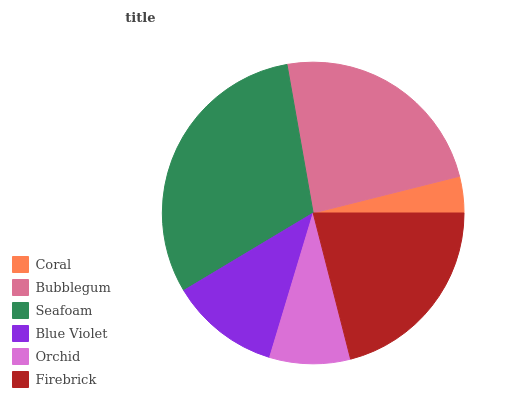Is Coral the minimum?
Answer yes or no. Yes. Is Seafoam the maximum?
Answer yes or no. Yes. Is Bubblegum the minimum?
Answer yes or no. No. Is Bubblegum the maximum?
Answer yes or no. No. Is Bubblegum greater than Coral?
Answer yes or no. Yes. Is Coral less than Bubblegum?
Answer yes or no. Yes. Is Coral greater than Bubblegum?
Answer yes or no. No. Is Bubblegum less than Coral?
Answer yes or no. No. Is Firebrick the high median?
Answer yes or no. Yes. Is Blue Violet the low median?
Answer yes or no. Yes. Is Bubblegum the high median?
Answer yes or no. No. Is Orchid the low median?
Answer yes or no. No. 